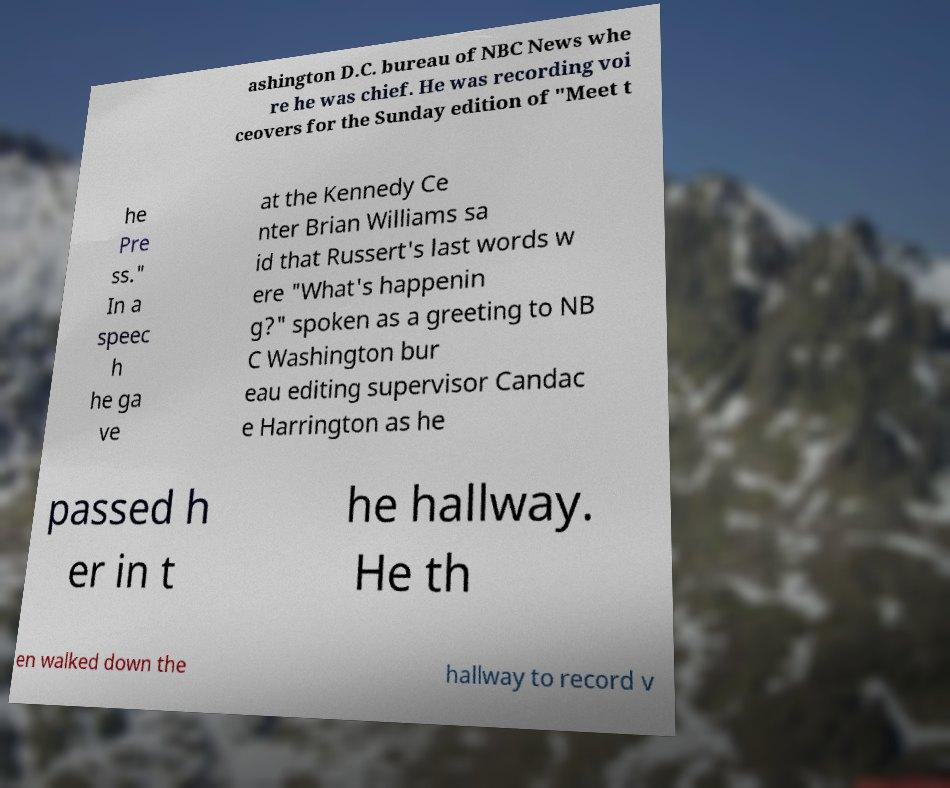Please identify and transcribe the text found in this image. ashington D.C. bureau of NBC News whe re he was chief. He was recording voi ceovers for the Sunday edition of "Meet t he Pre ss." In a speec h he ga ve at the Kennedy Ce nter Brian Williams sa id that Russert's last words w ere "What's happenin g?" spoken as a greeting to NB C Washington bur eau editing supervisor Candac e Harrington as he passed h er in t he hallway. He th en walked down the hallway to record v 